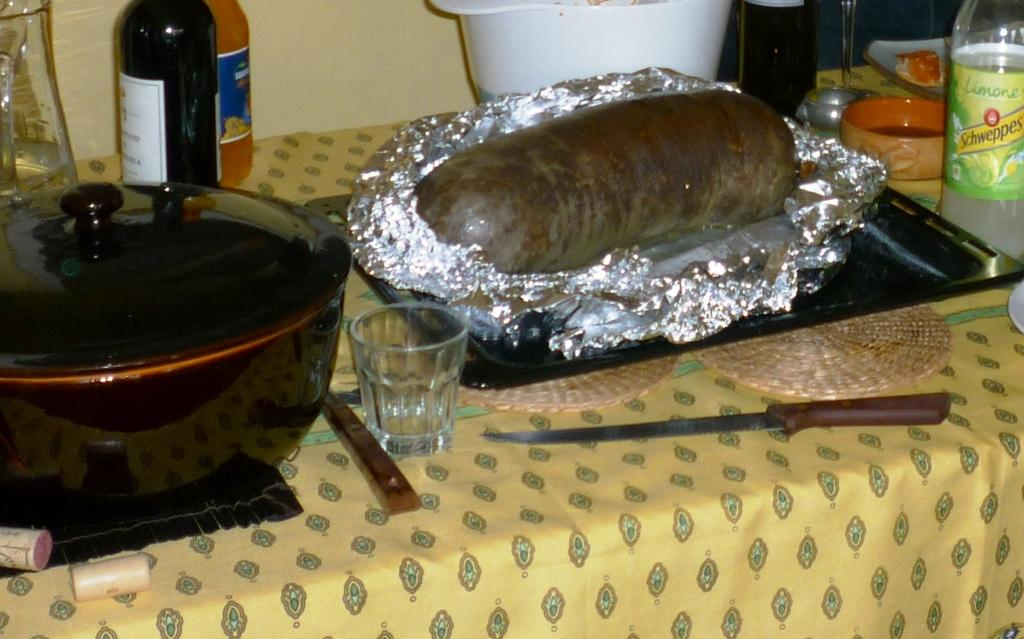Provide a one-sentence caption for the provided image. A bottle of Schweppes is on a table next to a foil wrapped food loaf and a pot. 